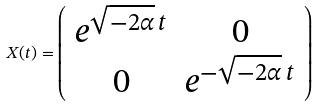<formula> <loc_0><loc_0><loc_500><loc_500>X ( t ) = \left ( \begin{array} { c c } e ^ { \sqrt { - 2 \alpha } \, t } & 0 \\ 0 & e ^ { - \sqrt { - 2 \alpha } \, t } \end{array} \right )</formula> 